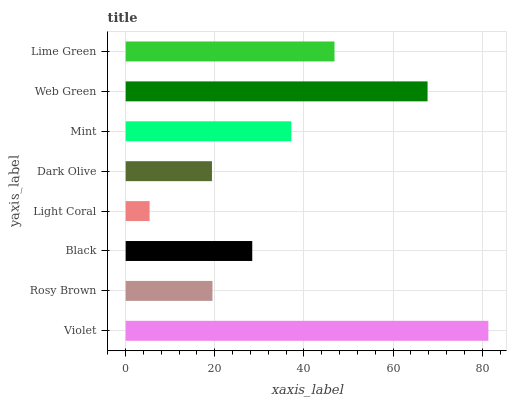Is Light Coral the minimum?
Answer yes or no. Yes. Is Violet the maximum?
Answer yes or no. Yes. Is Rosy Brown the minimum?
Answer yes or no. No. Is Rosy Brown the maximum?
Answer yes or no. No. Is Violet greater than Rosy Brown?
Answer yes or no. Yes. Is Rosy Brown less than Violet?
Answer yes or no. Yes. Is Rosy Brown greater than Violet?
Answer yes or no. No. Is Violet less than Rosy Brown?
Answer yes or no. No. Is Mint the high median?
Answer yes or no. Yes. Is Black the low median?
Answer yes or no. Yes. Is Dark Olive the high median?
Answer yes or no. No. Is Mint the low median?
Answer yes or no. No. 